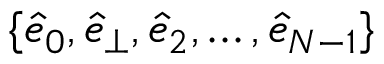<formula> <loc_0><loc_0><loc_500><loc_500>\{ \hat { e } _ { 0 } , \hat { e } _ { \perp } , \hat { e } _ { 2 } , \dots , \hat { e } _ { N - 1 } \}</formula> 